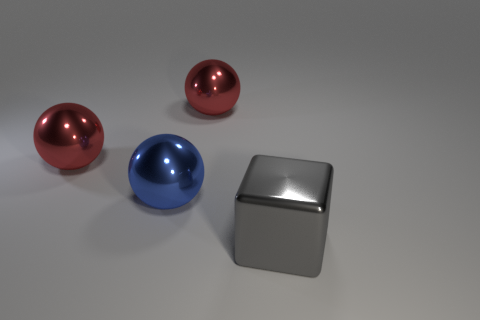Does the large gray thing have the same shape as the blue thing?
Your response must be concise. No. Are the big gray object that is in front of the blue shiny ball and the large red thing on the left side of the blue metallic thing made of the same material?
Offer a very short reply. Yes. How many things are either objects to the left of the metallic cube or metallic objects behind the gray object?
Ensure brevity in your answer.  3. Is there anything else that has the same shape as the gray shiny thing?
Your response must be concise. No. What number of spheres are there?
Your answer should be compact. 3. Are there any red shiny spheres that have the same size as the blue shiny ball?
Your answer should be very brief. Yes. Is the big gray thing made of the same material as the big sphere that is on the left side of the blue thing?
Make the answer very short. Yes. What is the big thing that is on the left side of the blue shiny ball made of?
Your answer should be very brief. Metal. What size is the gray metal block?
Provide a short and direct response. Large. There is a red ball to the right of the blue thing; does it have the same size as the red sphere on the left side of the blue metallic thing?
Provide a succinct answer. Yes. 